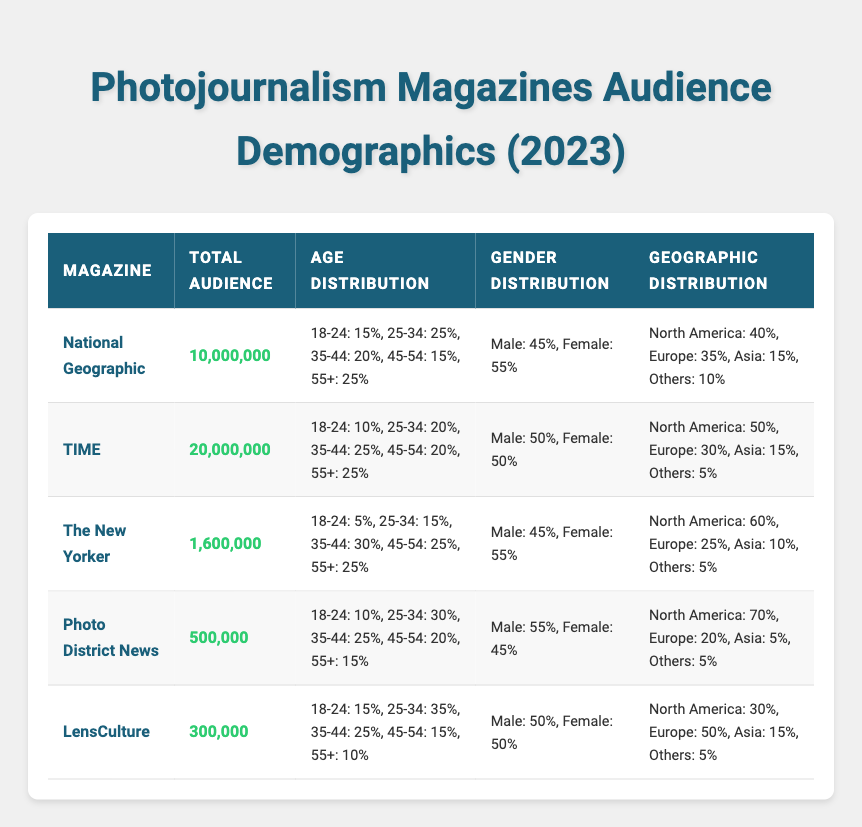What is the total audience of TIME magazine? The total audience for TIME magazine is explicitly mentioned in the table as 20,000,000.
Answer: 20,000,000 Which magazine has the highest percentage of female readers? According to the gender distribution data in the table, both National Geographic and The New Yorker have 55% female readers, which is the highest percentage among the listed magazines.
Answer: National Geographic and The New Yorker What is the average age percentage of readers aged 25-34 across all magazines? To calculate the average for the age group 25-34, sum the percentages (25 + 20 + 15 + 30 + 35) = 125 and divide by the number of magazines (5), resulting in an average percentage of 125/5 = 25%.
Answer: 25% Does LensCulture have more readers from North America than The New Yorker? LensCulture has 30% of its audience from North America, whereas The New Yorker has 60%. Therefore, LensCulture does not have more readers from North America.
Answer: No Which age group has the lowest representation among the readers of The New Yorker? The lowest representation in the age distribution for The New Yorker is in the age group 18-24, with only 5%.
Answer: 18-24 How much of the total audience does Photo District News represent compared to National Geographic? Photo District News has an audience of 500,000, and National Geographic has 10,000,000. To find the comparison, divide Photo District News's total audience by National Geographic's: 500,000/10,000,000 = 0.05, meaning Photo District News represents 5% of National Geographic's audience.
Answer: 5% Does TIME magazine have an equal gender distribution? The gender distribution for TIME magazine is 50% male and 50% female, indicating an equal distribution between genders.
Answer: Yes Which magazine has the smallest total audience and what is that audience size? The data shows that LensCulture has the smallest total audience of 300,000.
Answer: 300,000 What is the combined percentage of readers aged 45-54 for National Geographic and TIME? For National Geographic, the percentage of readers aged 45-54 is 15%, and for TIME, it is also 20%. Adding these together gives 15 + 20 = 35%.
Answer: 35% 